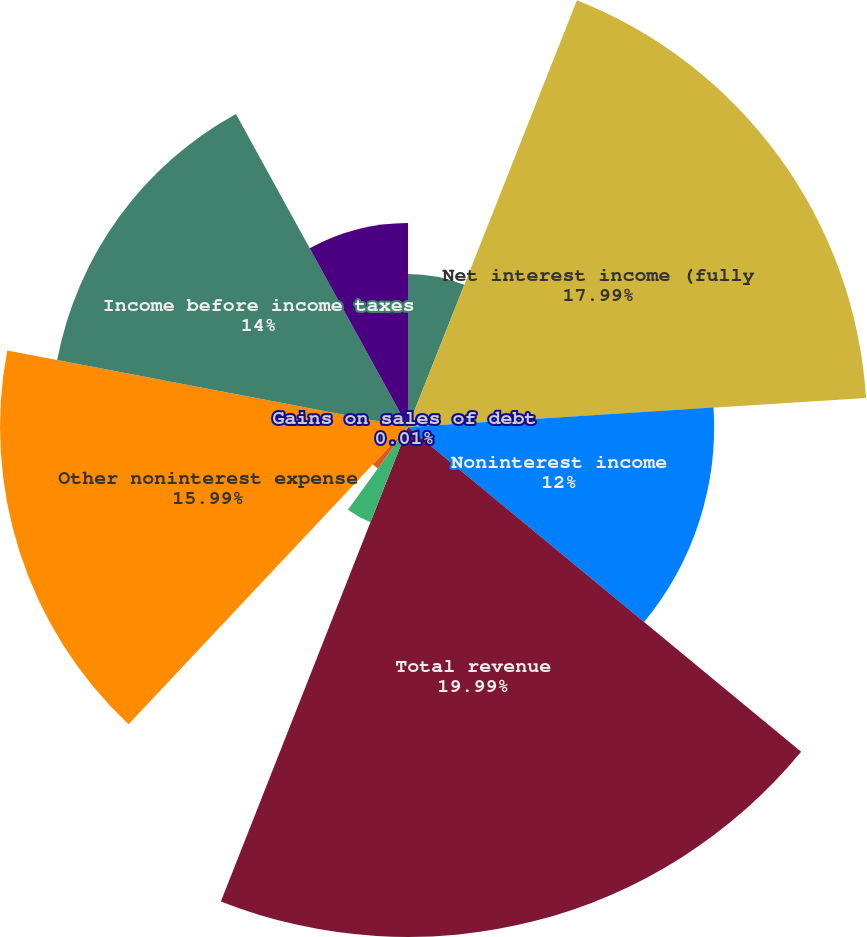<chart> <loc_0><loc_0><loc_500><loc_500><pie_chart><fcel>(Dollars in millions)<fcel>Net interest income (fully<fcel>Noninterest income<fcel>Total revenue<fcel>Provision for credit losses<fcel>Gains on sales of debt<fcel>Amortization of intangibles<fcel>Other noninterest expense<fcel>Income before income taxes<fcel>Income tax expense<nl><fcel>6.0%<fcel>17.99%<fcel>12.0%<fcel>19.99%<fcel>4.01%<fcel>0.01%<fcel>2.01%<fcel>15.99%<fcel>14.0%<fcel>8.0%<nl></chart> 